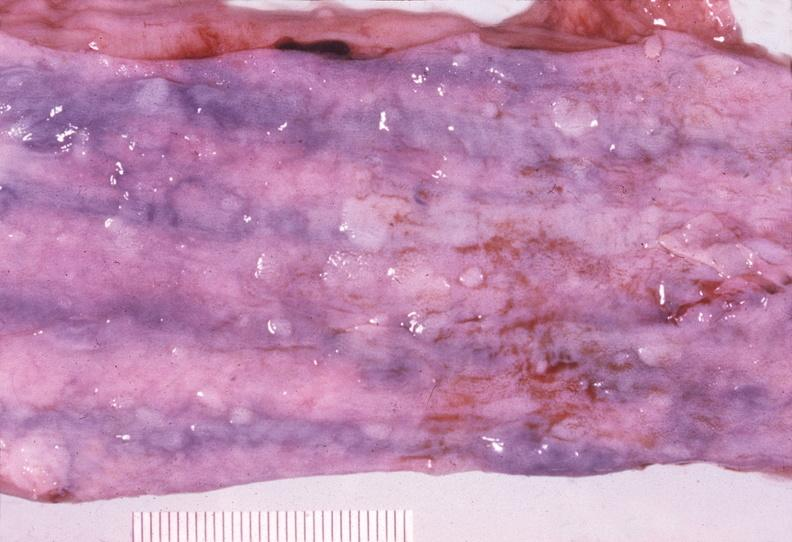where does this belong to?
Answer the question using a single word or phrase. Gastrointestinal system 